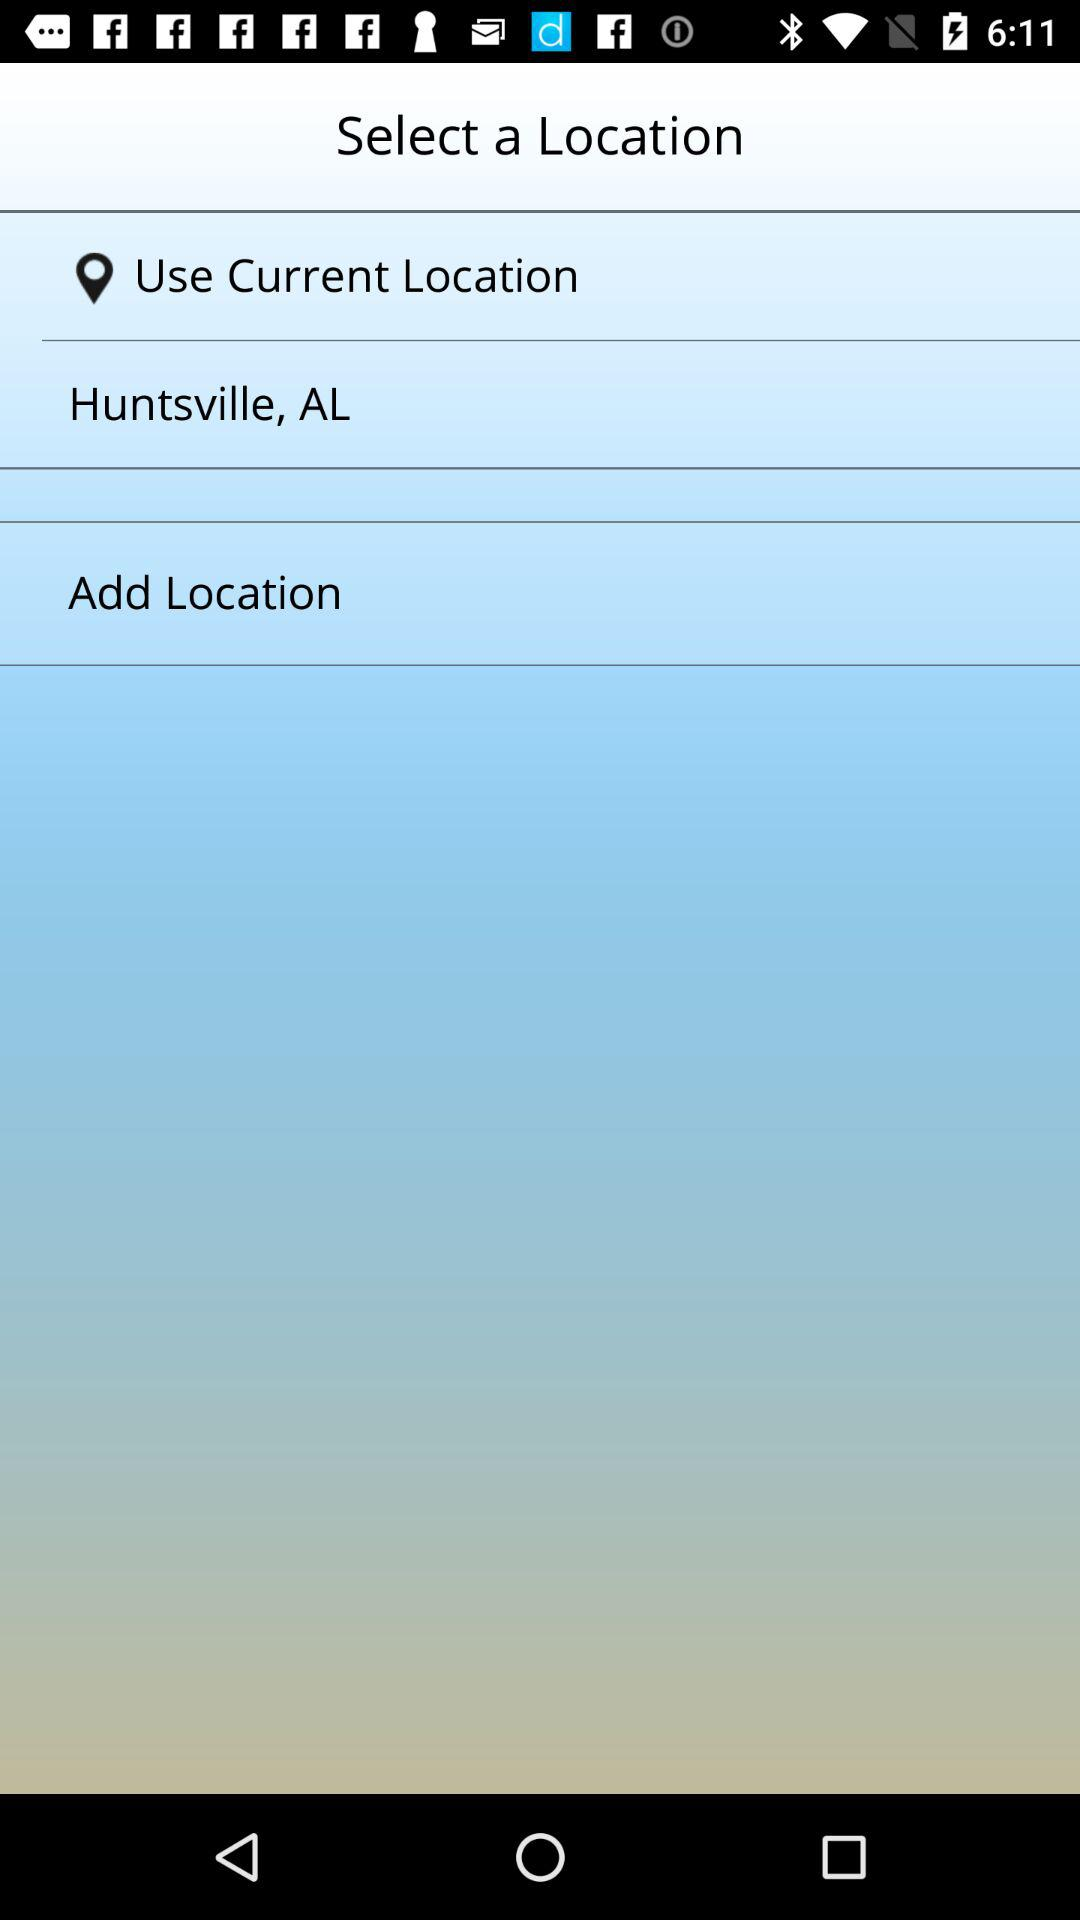How many locations are available to select?
Answer the question using a single word or phrase. 2 